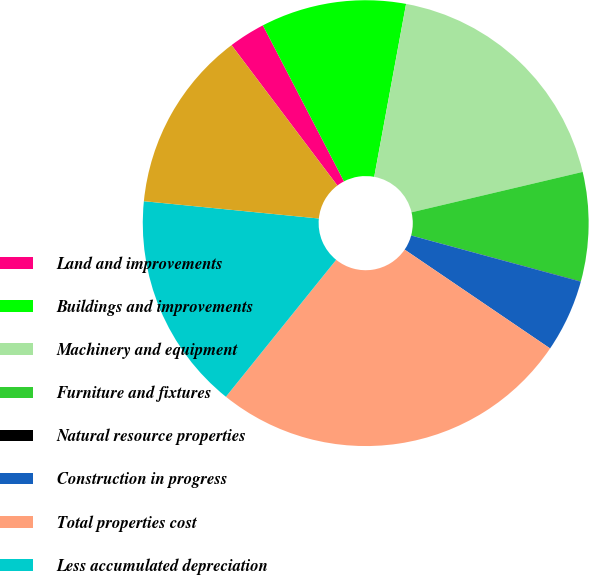Convert chart. <chart><loc_0><loc_0><loc_500><loc_500><pie_chart><fcel>Land and improvements<fcel>Buildings and improvements<fcel>Machinery and equipment<fcel>Furniture and fixtures<fcel>Natural resource properties<fcel>Construction in progress<fcel>Total properties cost<fcel>Less accumulated depreciation<fcel>Netproperties<nl><fcel>2.65%<fcel>10.53%<fcel>18.41%<fcel>7.9%<fcel>0.02%<fcel>5.27%<fcel>26.29%<fcel>15.78%<fcel>13.15%<nl></chart> 